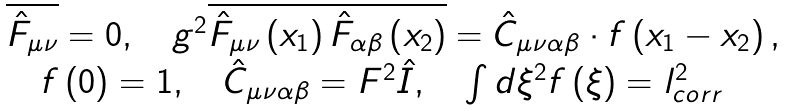Convert formula to latex. <formula><loc_0><loc_0><loc_500><loc_500>\begin{array} { l } \overline { \hat { F } _ { \mu \nu } } = 0 , \quad g ^ { 2 } \overline { \hat { F } _ { \mu \nu } \left ( { x _ { 1 } } \right ) \hat { F } _ { \alpha \beta } \left ( x _ { 2 } \right ) } = \hat { C } _ { \mu \nu \alpha \beta } \cdot f \left ( x _ { 1 } - x _ { 2 } \right ) , \\ \quad f \left ( 0 \right ) = 1 , \quad \hat { C } _ { \mu \nu \alpha \beta } = F ^ { 2 } \hat { I } , \quad \int { d \xi ^ { 2 } f \left ( { \xi } \right ) } = l _ { c o r r } ^ { 2 } \end{array}</formula> 